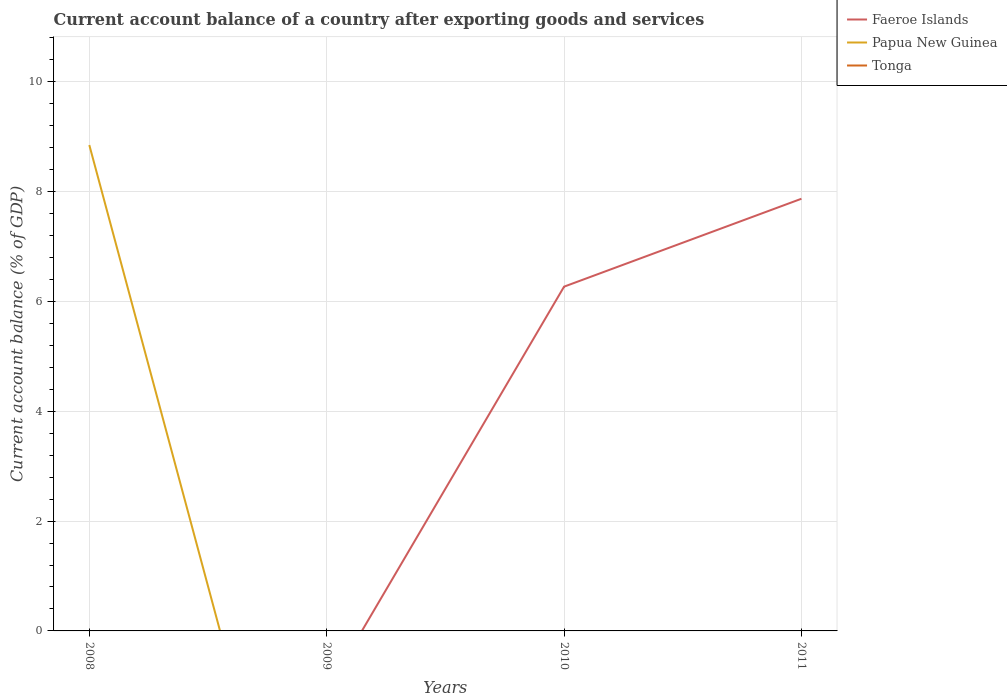Does the line corresponding to Tonga intersect with the line corresponding to Faeroe Islands?
Provide a short and direct response. No. Across all years, what is the maximum account balance in Faeroe Islands?
Provide a short and direct response. 0. What is the difference between the highest and the second highest account balance in Papua New Guinea?
Provide a short and direct response. 8.85. Is the account balance in Papua New Guinea strictly greater than the account balance in Tonga over the years?
Your response must be concise. No. What is the difference between two consecutive major ticks on the Y-axis?
Ensure brevity in your answer.  2. Are the values on the major ticks of Y-axis written in scientific E-notation?
Your response must be concise. No. Does the graph contain any zero values?
Ensure brevity in your answer.  Yes. Does the graph contain grids?
Offer a very short reply. Yes. How many legend labels are there?
Your response must be concise. 3. What is the title of the graph?
Your answer should be very brief. Current account balance of a country after exporting goods and services. What is the label or title of the Y-axis?
Make the answer very short. Current account balance (% of GDP). What is the Current account balance (% of GDP) in Papua New Guinea in 2008?
Provide a succinct answer. 8.85. What is the Current account balance (% of GDP) of Faeroe Islands in 2009?
Make the answer very short. 0. What is the Current account balance (% of GDP) in Papua New Guinea in 2009?
Give a very brief answer. 0. What is the Current account balance (% of GDP) in Faeroe Islands in 2010?
Offer a very short reply. 6.27. What is the Current account balance (% of GDP) of Tonga in 2010?
Give a very brief answer. 0. What is the Current account balance (% of GDP) of Faeroe Islands in 2011?
Provide a succinct answer. 7.87. Across all years, what is the maximum Current account balance (% of GDP) of Faeroe Islands?
Offer a very short reply. 7.87. Across all years, what is the maximum Current account balance (% of GDP) of Papua New Guinea?
Your answer should be very brief. 8.85. What is the total Current account balance (% of GDP) in Faeroe Islands in the graph?
Your response must be concise. 14.14. What is the total Current account balance (% of GDP) in Papua New Guinea in the graph?
Provide a succinct answer. 8.85. What is the total Current account balance (% of GDP) in Tonga in the graph?
Offer a very short reply. 0. What is the difference between the Current account balance (% of GDP) in Faeroe Islands in 2010 and that in 2011?
Provide a succinct answer. -1.6. What is the average Current account balance (% of GDP) in Faeroe Islands per year?
Keep it short and to the point. 3.54. What is the average Current account balance (% of GDP) of Papua New Guinea per year?
Make the answer very short. 2.21. What is the ratio of the Current account balance (% of GDP) in Faeroe Islands in 2010 to that in 2011?
Give a very brief answer. 0.8. What is the difference between the highest and the lowest Current account balance (% of GDP) of Faeroe Islands?
Provide a succinct answer. 7.87. What is the difference between the highest and the lowest Current account balance (% of GDP) of Papua New Guinea?
Your answer should be compact. 8.85. 